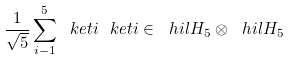Convert formula to latex. <formula><loc_0><loc_0><loc_500><loc_500>\frac { 1 } { \sqrt { 5 } } \sum _ { i - 1 } ^ { 5 } \ k e t { i } \ k e t { i } \in \ h i l { H } _ { 5 } \otimes \ h i l { H } _ { 5 }</formula> 